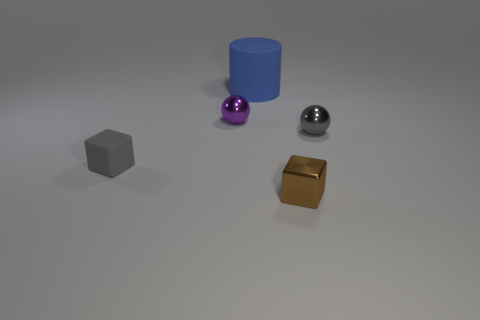Add 2 small gray metal things. How many objects exist? 7 Subtract all cylinders. How many objects are left? 4 Add 5 small matte cubes. How many small matte cubes are left? 6 Add 5 purple objects. How many purple objects exist? 6 Subtract 0 green spheres. How many objects are left? 5 Subtract all small brown balls. Subtract all big matte cylinders. How many objects are left? 4 